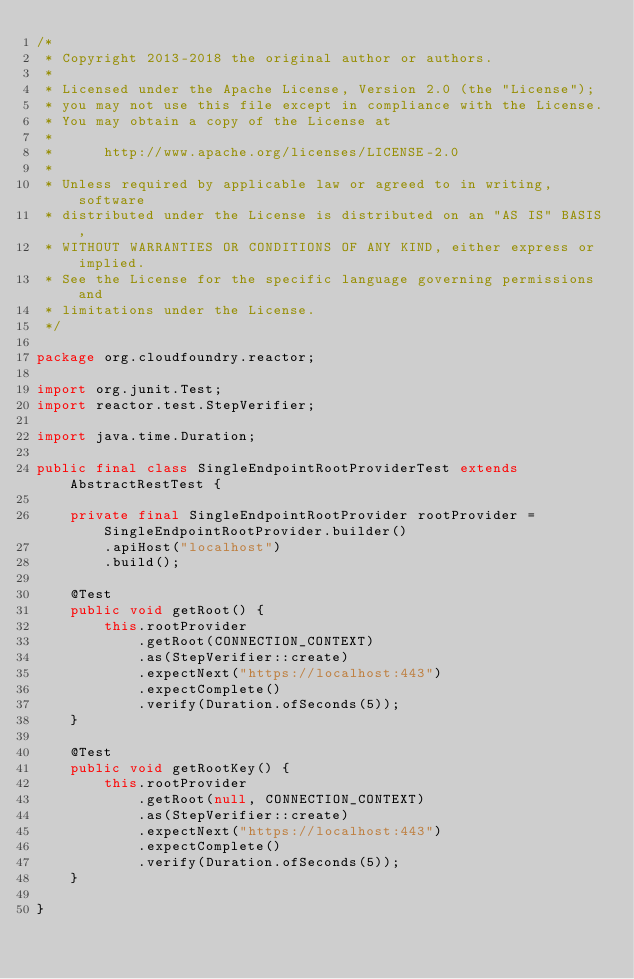<code> <loc_0><loc_0><loc_500><loc_500><_Java_>/*
 * Copyright 2013-2018 the original author or authors.
 *
 * Licensed under the Apache License, Version 2.0 (the "License");
 * you may not use this file except in compliance with the License.
 * You may obtain a copy of the License at
 *
 *      http://www.apache.org/licenses/LICENSE-2.0
 *
 * Unless required by applicable law or agreed to in writing, software
 * distributed under the License is distributed on an "AS IS" BASIS,
 * WITHOUT WARRANTIES OR CONDITIONS OF ANY KIND, either express or implied.
 * See the License for the specific language governing permissions and
 * limitations under the License.
 */

package org.cloudfoundry.reactor;

import org.junit.Test;
import reactor.test.StepVerifier;

import java.time.Duration;

public final class SingleEndpointRootProviderTest extends AbstractRestTest {

    private final SingleEndpointRootProvider rootProvider = SingleEndpointRootProvider.builder()
        .apiHost("localhost")
        .build();

    @Test
    public void getRoot() {
        this.rootProvider
            .getRoot(CONNECTION_CONTEXT)
            .as(StepVerifier::create)
            .expectNext("https://localhost:443")
            .expectComplete()
            .verify(Duration.ofSeconds(5));
    }

    @Test
    public void getRootKey() {
        this.rootProvider
            .getRoot(null, CONNECTION_CONTEXT)
            .as(StepVerifier::create)
            .expectNext("https://localhost:443")
            .expectComplete()
            .verify(Duration.ofSeconds(5));
    }

}
</code> 